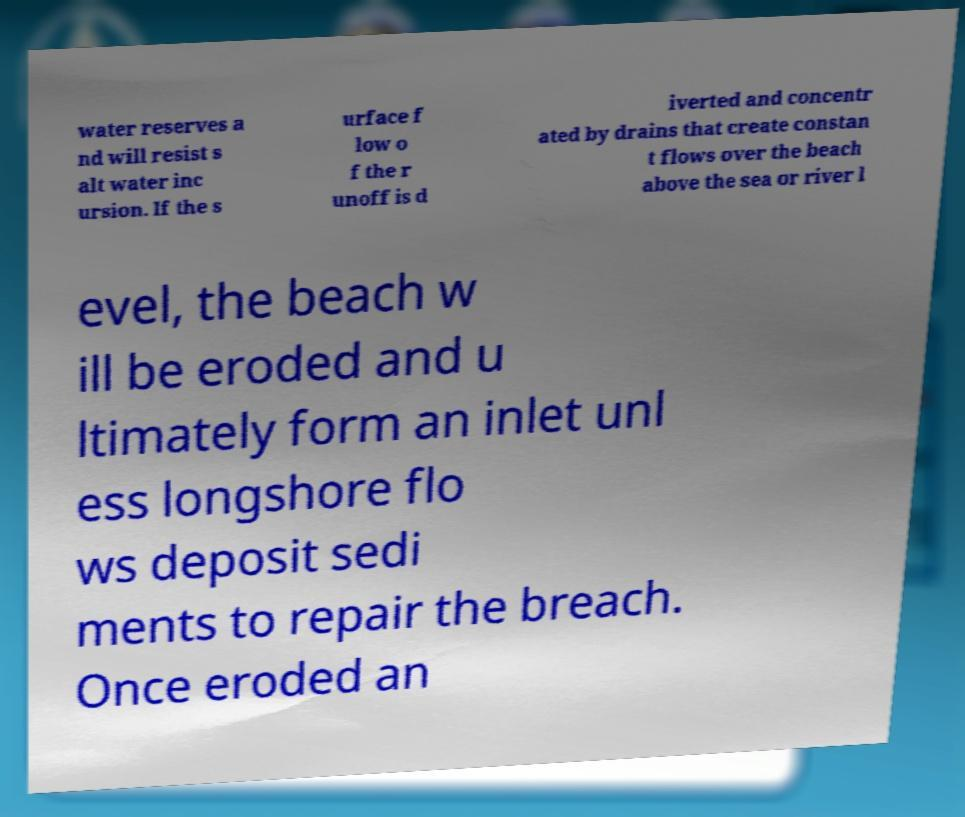For documentation purposes, I need the text within this image transcribed. Could you provide that? water reserves a nd will resist s alt water inc ursion. If the s urface f low o f the r unoff is d iverted and concentr ated by drains that create constan t flows over the beach above the sea or river l evel, the beach w ill be eroded and u ltimately form an inlet unl ess longshore flo ws deposit sedi ments to repair the breach. Once eroded an 